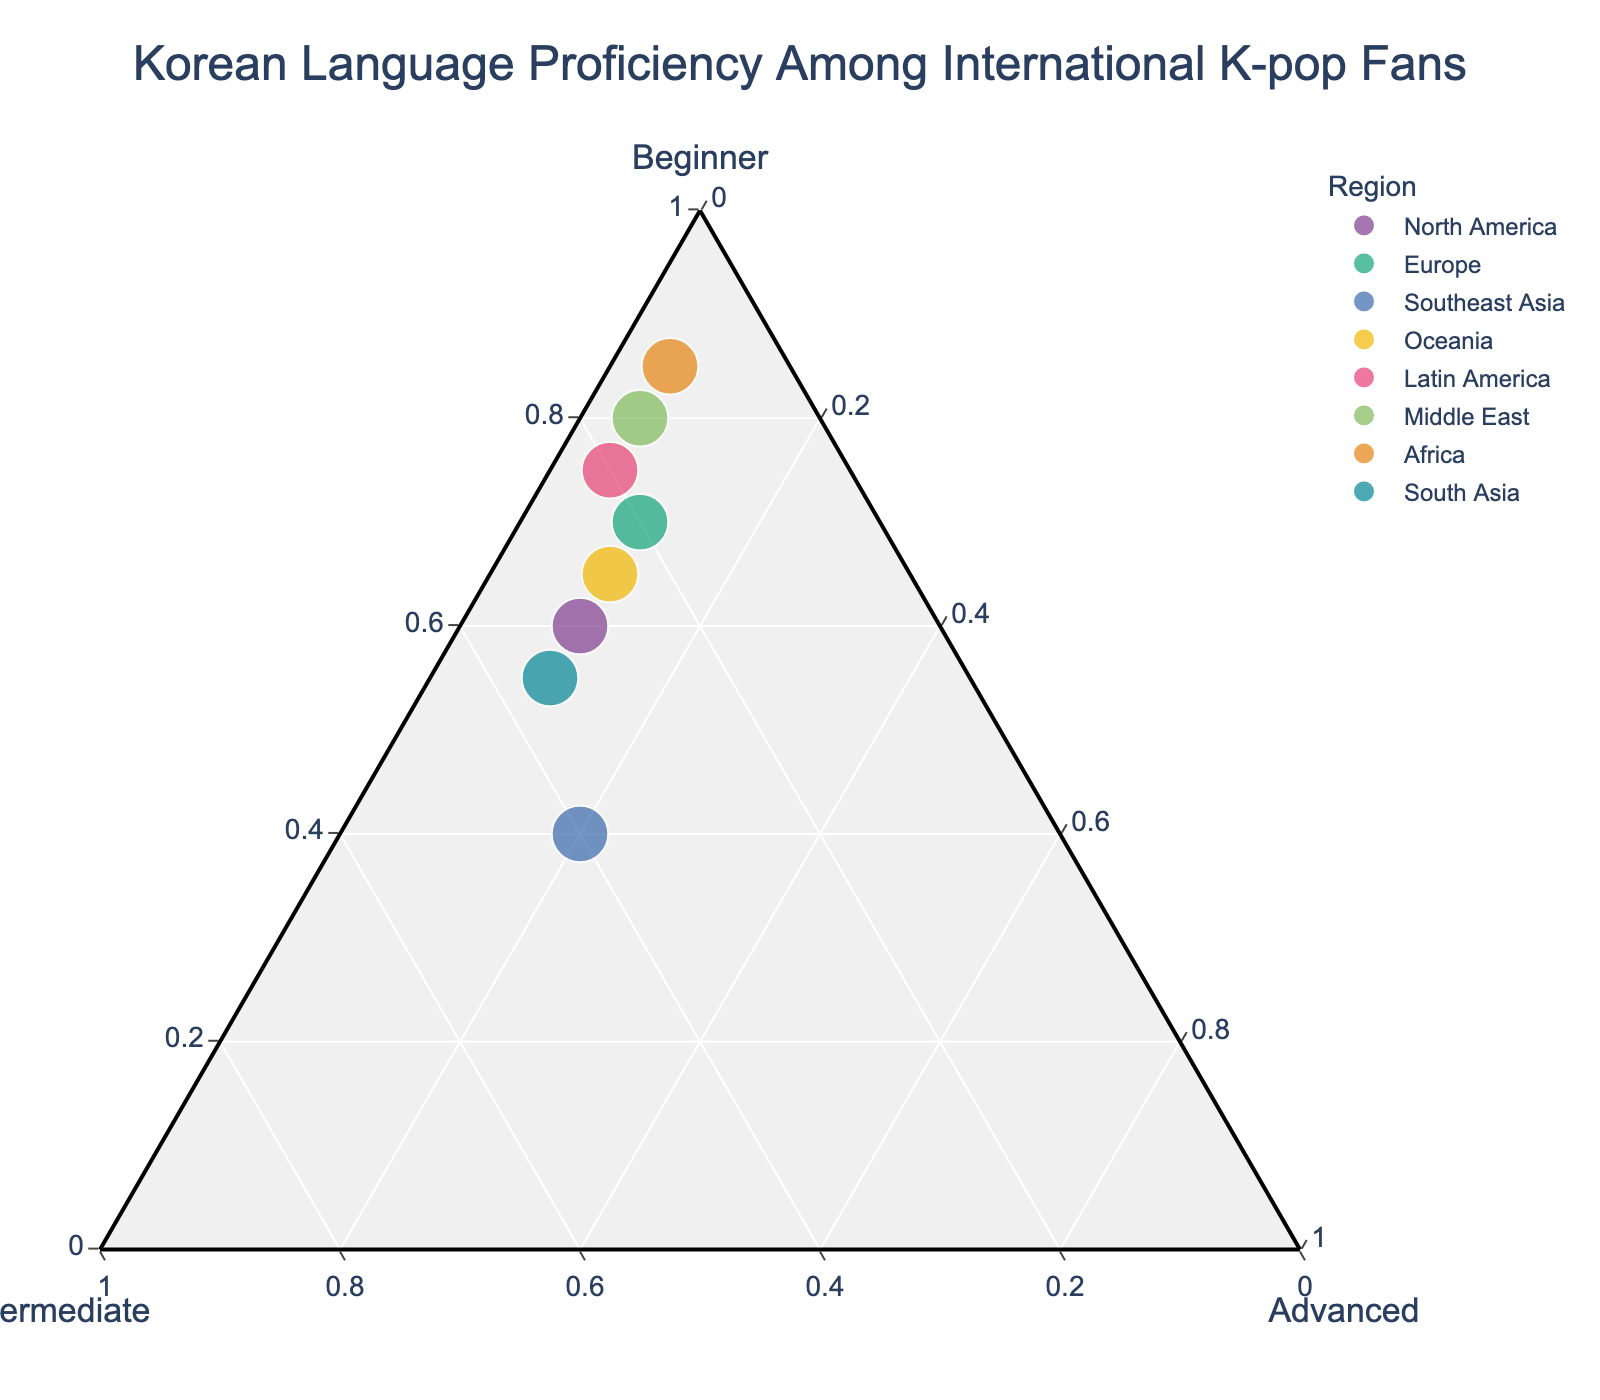Which region has the highest proportion of beginner proficiency in Korean? The plot shows Africa has the highest proportion of beginner proficiency as it is closest to the "Beginner" vertex.
Answer: Africa Which region has the largest proportion of intermediate proficiency in Korean? Southeast Asia is the region closest to the "Intermediate" vertex, indicating the highest proportion of intermediate proficiency.
Answer: Southeast Asia What is the title of the plot? The title is prominently located at the top of the figure.
Answer: Korean Language Proficiency Among International K-pop Fans In which region is the proportion of advanced proficiency the highest? The region with the highest proportion of advanced proficiency is Southeast Asia, closest to the "Advanced" vertex.
Answer: Southeast Asia How many regions have more than 70% beginner proficiency? By observing the position of the regions relative to the "Beginner" vertex, four regions (Europe, Latin America, Middle East, Africa) have more than 70% beginner proficiency.
Answer: Four Which region has the most balanced proportions of beginner, intermediate, and advanced proficiency? South Asia is closest to the center of the plot, indicating the most balanced proportions.
Answer: South Asia Compare the proportion of beginner proficiency between North America and Europe. Which has a higher percentage? By comparing the positions, Europe’s point is closer to the "Beginner" vertex than North America's point, indicating a higher beginner proficiency.
Answer: Europe What is the combined proportion of intermediate and advanced proficiency in North America? North America's intermediate proportion is 0.3 and advanced proportion is 0.1. Adding them gives 0.3 + 0.1 = 0.4 or 40%.
Answer: 40% Which two regions have the same proportion of advanced proficiency? Observing the plot, Latin America, Middle East, and Africa are all aligned at an advanced proficiency level of 0.05.
Answer: Latin America, Middle East, Africa Is Oceania’s proportion of intermediate proficiency higher or lower than North America’s? Oceania's intermediate point lies closer to the "Intermediate" vertex compared to North America's, thus it’s higher.
Answer: Higher 